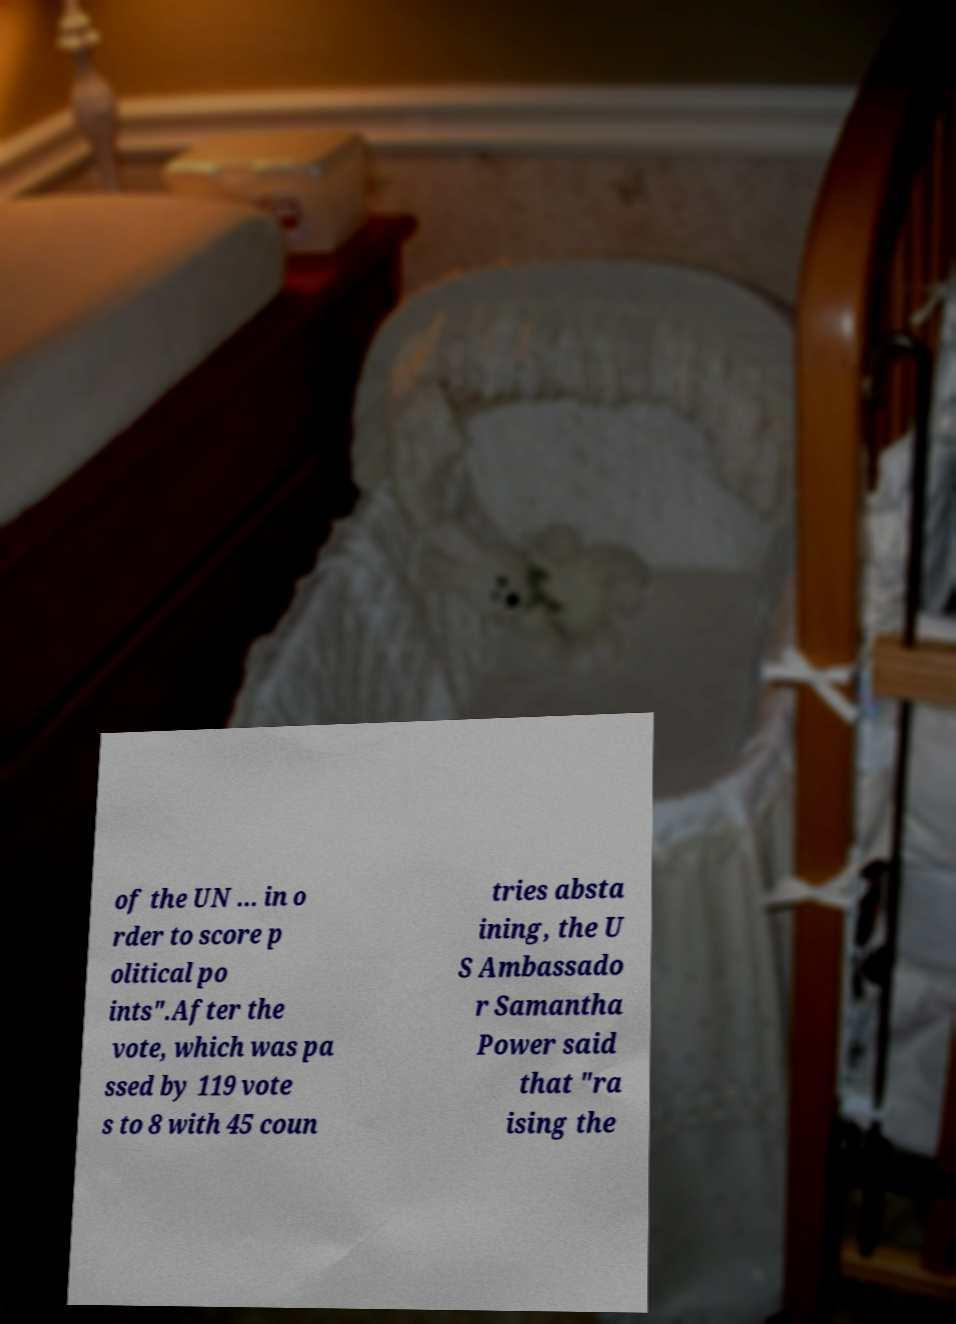Could you assist in decoding the text presented in this image and type it out clearly? of the UN ... in o rder to score p olitical po ints".After the vote, which was pa ssed by 119 vote s to 8 with 45 coun tries absta ining, the U S Ambassado r Samantha Power said that "ra ising the 